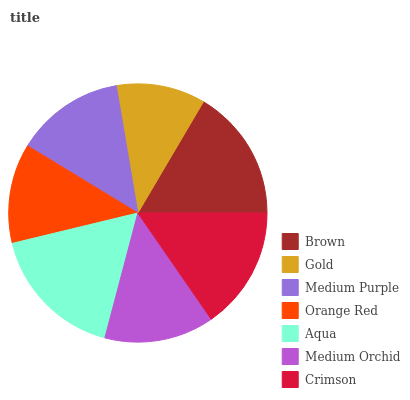Is Gold the minimum?
Answer yes or no. Yes. Is Aqua the maximum?
Answer yes or no. Yes. Is Medium Purple the minimum?
Answer yes or no. No. Is Medium Purple the maximum?
Answer yes or no. No. Is Medium Purple greater than Gold?
Answer yes or no. Yes. Is Gold less than Medium Purple?
Answer yes or no. Yes. Is Gold greater than Medium Purple?
Answer yes or no. No. Is Medium Purple less than Gold?
Answer yes or no. No. Is Medium Orchid the high median?
Answer yes or no. Yes. Is Medium Orchid the low median?
Answer yes or no. Yes. Is Gold the high median?
Answer yes or no. No. Is Gold the low median?
Answer yes or no. No. 